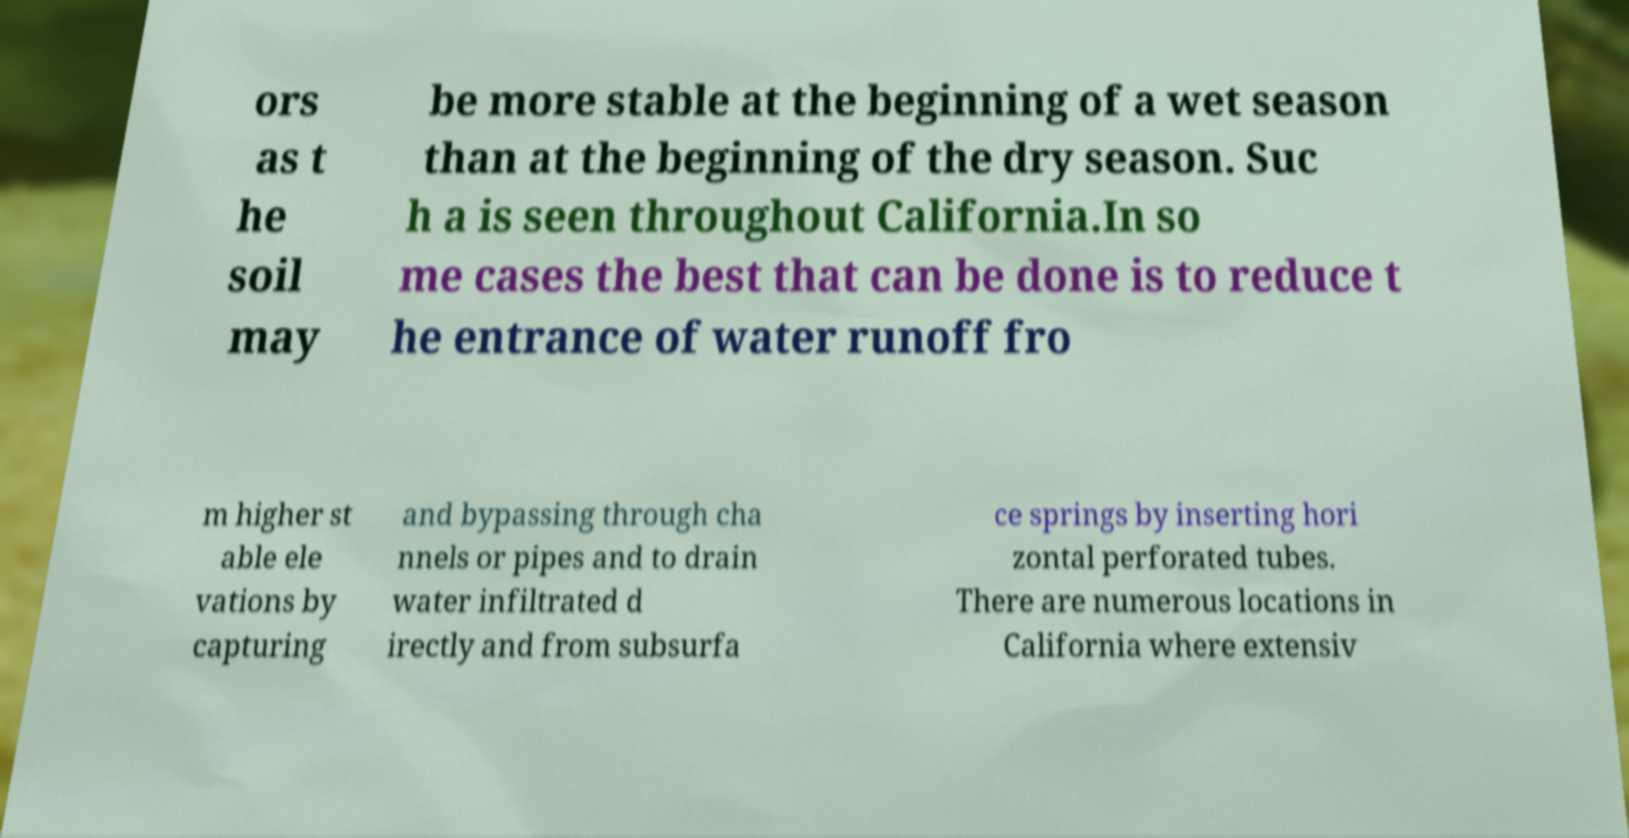I need the written content from this picture converted into text. Can you do that? ors as t he soil may be more stable at the beginning of a wet season than at the beginning of the dry season. Suc h a is seen throughout California.In so me cases the best that can be done is to reduce t he entrance of water runoff fro m higher st able ele vations by capturing and bypassing through cha nnels or pipes and to drain water infiltrated d irectly and from subsurfa ce springs by inserting hori zontal perforated tubes. There are numerous locations in California where extensiv 